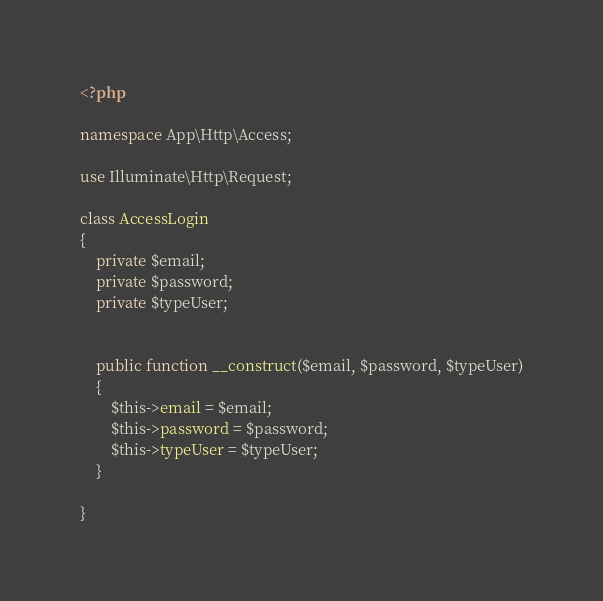Convert code to text. <code><loc_0><loc_0><loc_500><loc_500><_PHP_><?php

namespace App\Http\Access;

use Illuminate\Http\Request;

class AccessLogin 
{
    private $email;
    private $password;
    private $typeUser;


    public function __construct($email, $password, $typeUser)
    {
        $this->email = $email;
        $this->password = $password;
        $this->typeUser = $typeUser; 
    }

}
</code> 